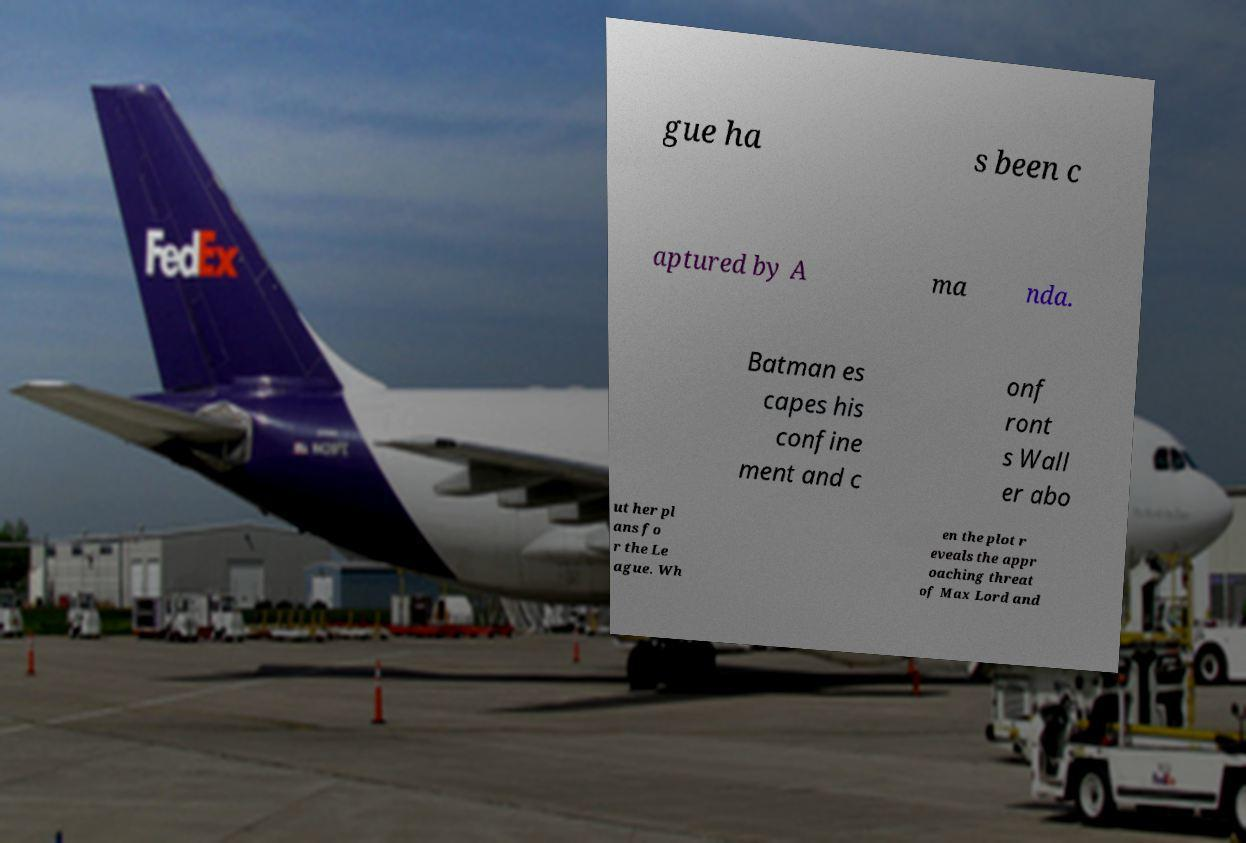Can you read and provide the text displayed in the image?This photo seems to have some interesting text. Can you extract and type it out for me? gue ha s been c aptured by A ma nda. Batman es capes his confine ment and c onf ront s Wall er abo ut her pl ans fo r the Le ague. Wh en the plot r eveals the appr oaching threat of Max Lord and 